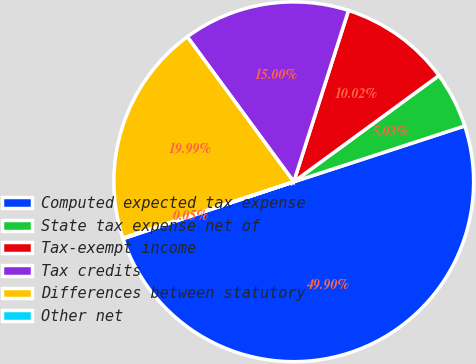<chart> <loc_0><loc_0><loc_500><loc_500><pie_chart><fcel>Computed expected tax expense<fcel>State tax expense net of<fcel>Tax-exempt income<fcel>Tax credits<fcel>Differences between statutory<fcel>Other net<nl><fcel>49.9%<fcel>5.03%<fcel>10.02%<fcel>15.0%<fcel>19.99%<fcel>0.05%<nl></chart> 